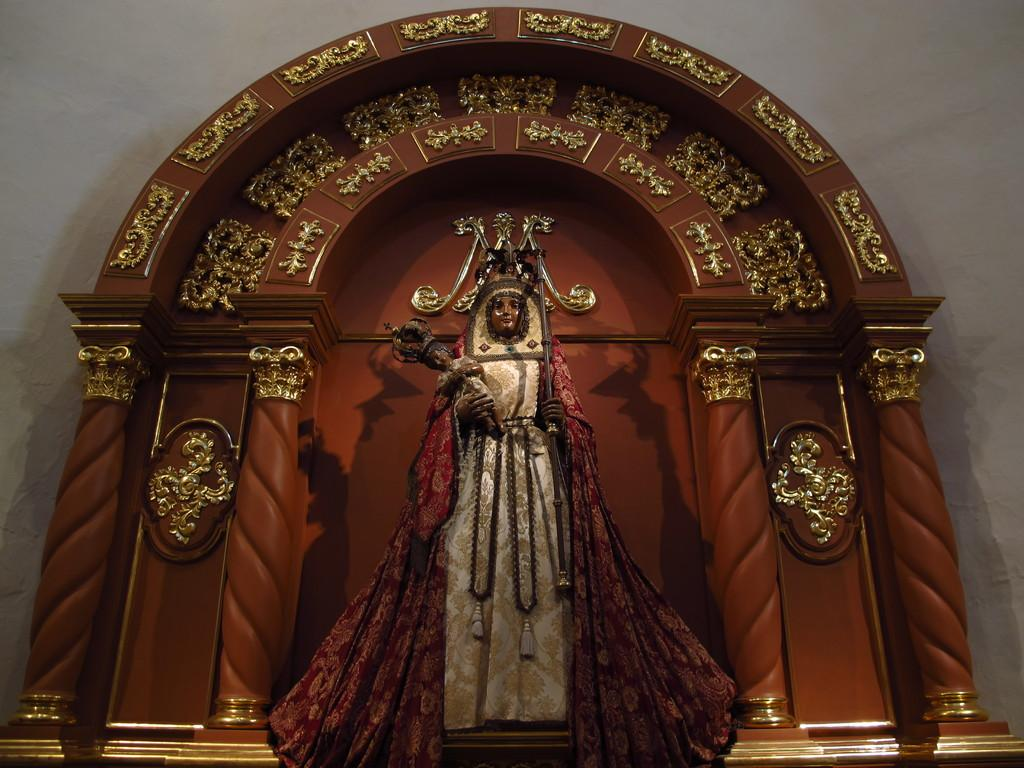What is the main subject of the image? There is a sculpture of a person standing in the image. What can be observed about the sculpture's attire? The sculpture is wearing clothes. What is the sculpture holding in its hand? The sculpture is holding an object in its hand. What type of architectural feature can be seen in the image? There is an arch construction in the image. What other structure is present in the image? There is a wall in the image. What type of flower is growing on the sculpture's head in the image? There are no flowers present on the sculpture's head in the image. What message of love is conveyed by the sculpture in the image? The sculpture does not convey any message of love in the image, as it is a static object. 